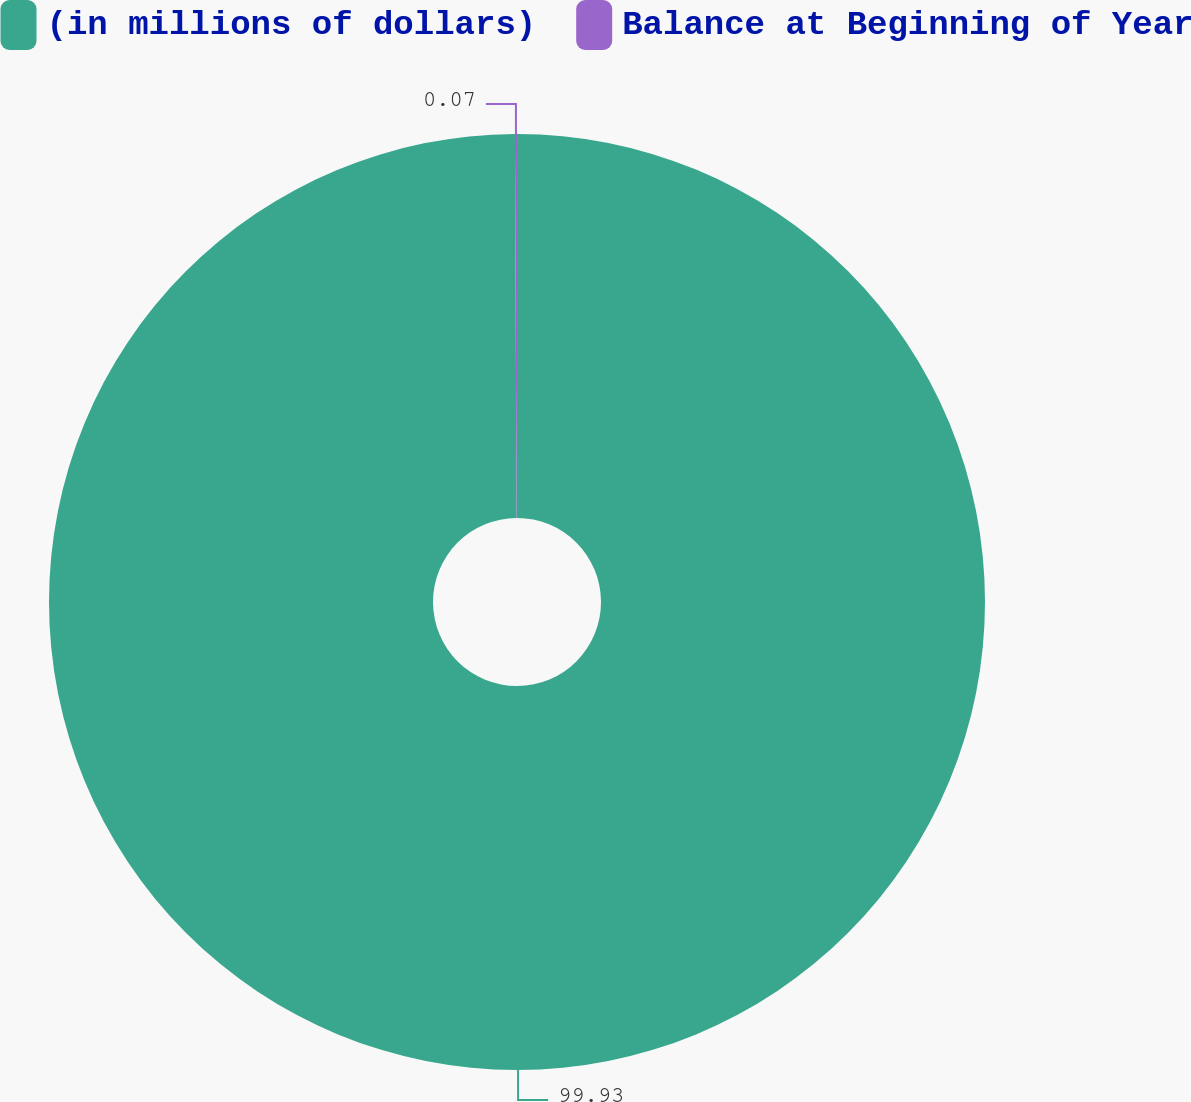Convert chart to OTSL. <chart><loc_0><loc_0><loc_500><loc_500><pie_chart><fcel>(in millions of dollars)<fcel>Balance at Beginning of Year<nl><fcel>99.93%<fcel>0.07%<nl></chart> 